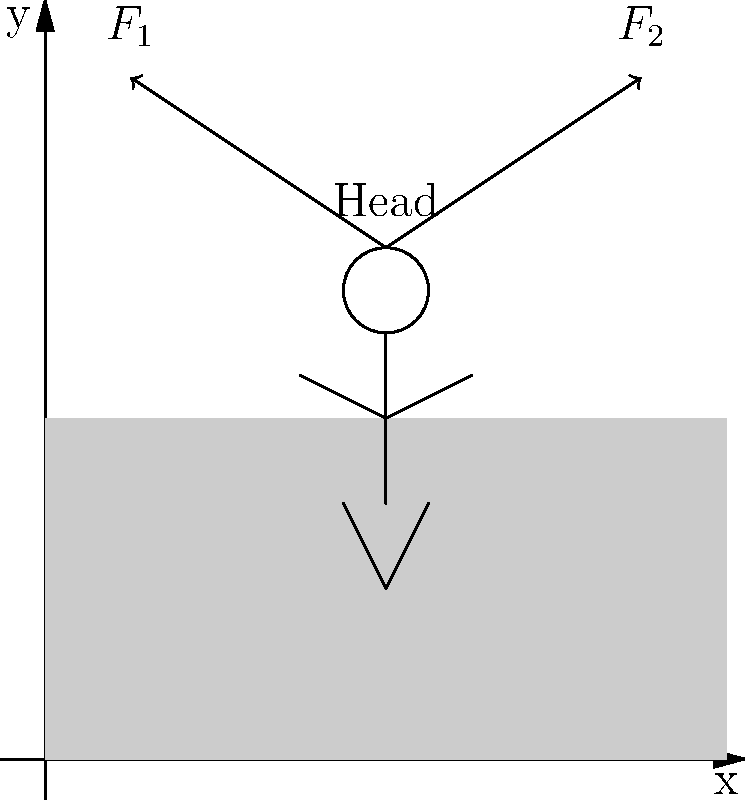In a frontal car collision, two primary forces act on a passenger's head as shown in the diagram. $F_1$ represents the initial forward force due to inertia, while $F_2$ represents the restraining force from a safety device. If the mass of the head is 4.5 kg and it experiences a maximum acceleration of 50 g's (where g = 9.8 m/s²), what is the magnitude of $F_1$ in Newtons? To solve this problem, we'll follow these steps:

1. Identify the given information:
   - Mass of the head (m) = 4.5 kg
   - Maximum acceleration (a) = 50 g's, where g = 9.8 m/s²

2. Convert the acceleration from g's to m/s²:
   a = 50 × 9.8 m/s² = 490 m/s²

3. Use Newton's Second Law of Motion to calculate the force:
   $F = ma$

   Where:
   F = force in Newtons (N)
   m = mass in kilograms (kg)
   a = acceleration in meters per second squared (m/s²)

4. Substitute the values into the equation:
   $F_1 = 4.5 \text{ kg} \times 490 \text{ m/s²}$

5. Calculate the result:
   $F_1 = 2205 \text{ N}$

Therefore, the magnitude of $F_1$ acting on the passenger's head during the collision is 2205 N.
Answer: 2205 N 